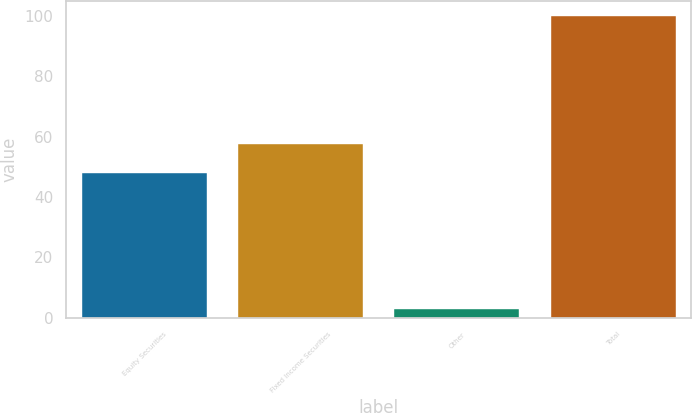Convert chart to OTSL. <chart><loc_0><loc_0><loc_500><loc_500><bar_chart><fcel>Equity Securities<fcel>Fixed Income Securities<fcel>Other<fcel>Total<nl><fcel>48<fcel>57.7<fcel>3<fcel>100<nl></chart> 